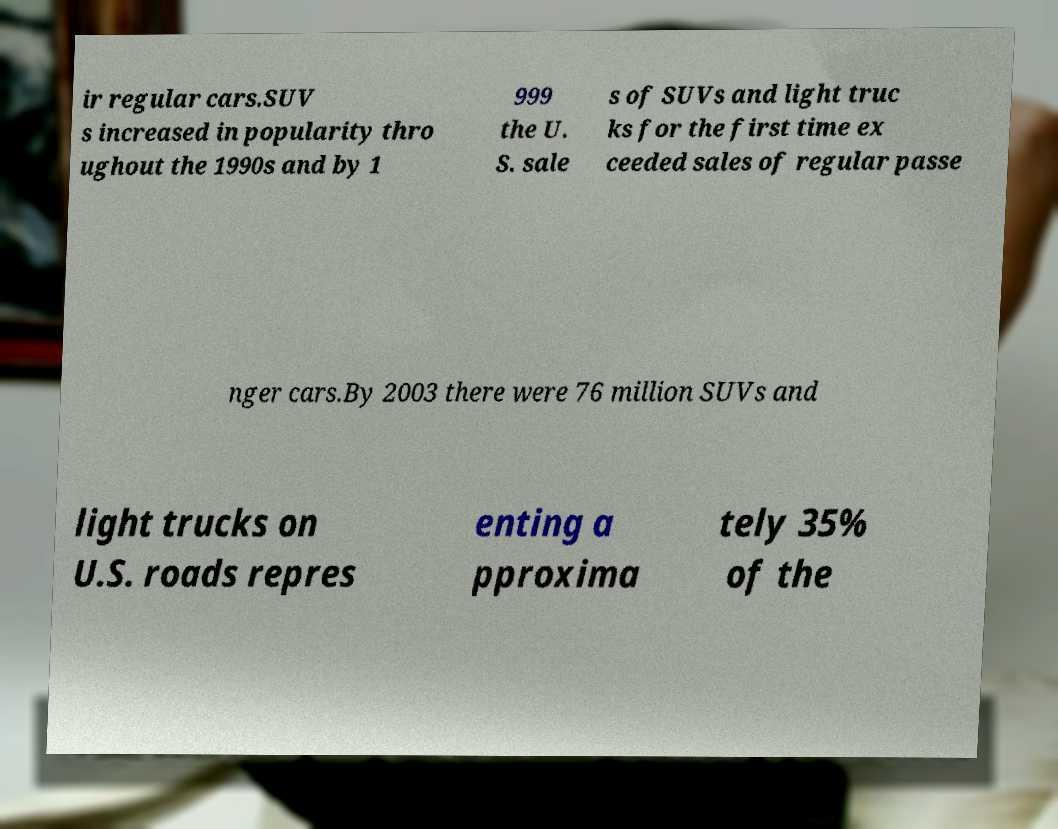Can you read and provide the text displayed in the image?This photo seems to have some interesting text. Can you extract and type it out for me? ir regular cars.SUV s increased in popularity thro ughout the 1990s and by 1 999 the U. S. sale s of SUVs and light truc ks for the first time ex ceeded sales of regular passe nger cars.By 2003 there were 76 million SUVs and light trucks on U.S. roads repres enting a pproxima tely 35% of the 